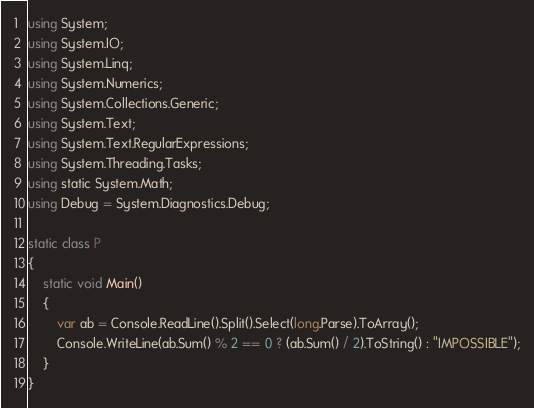Convert code to text. <code><loc_0><loc_0><loc_500><loc_500><_C#_>using System;
using System.IO;
using System.Linq;
using System.Numerics;
using System.Collections.Generic;
using System.Text;
using System.Text.RegularExpressions;
using System.Threading.Tasks;
using static System.Math;
using Debug = System.Diagnostics.Debug;

static class P
{
    static void Main()
    {
        var ab = Console.ReadLine().Split().Select(long.Parse).ToArray();
        Console.WriteLine(ab.Sum() % 2 == 0 ? (ab.Sum() / 2).ToString() : "IMPOSSIBLE");
    }
}
</code> 